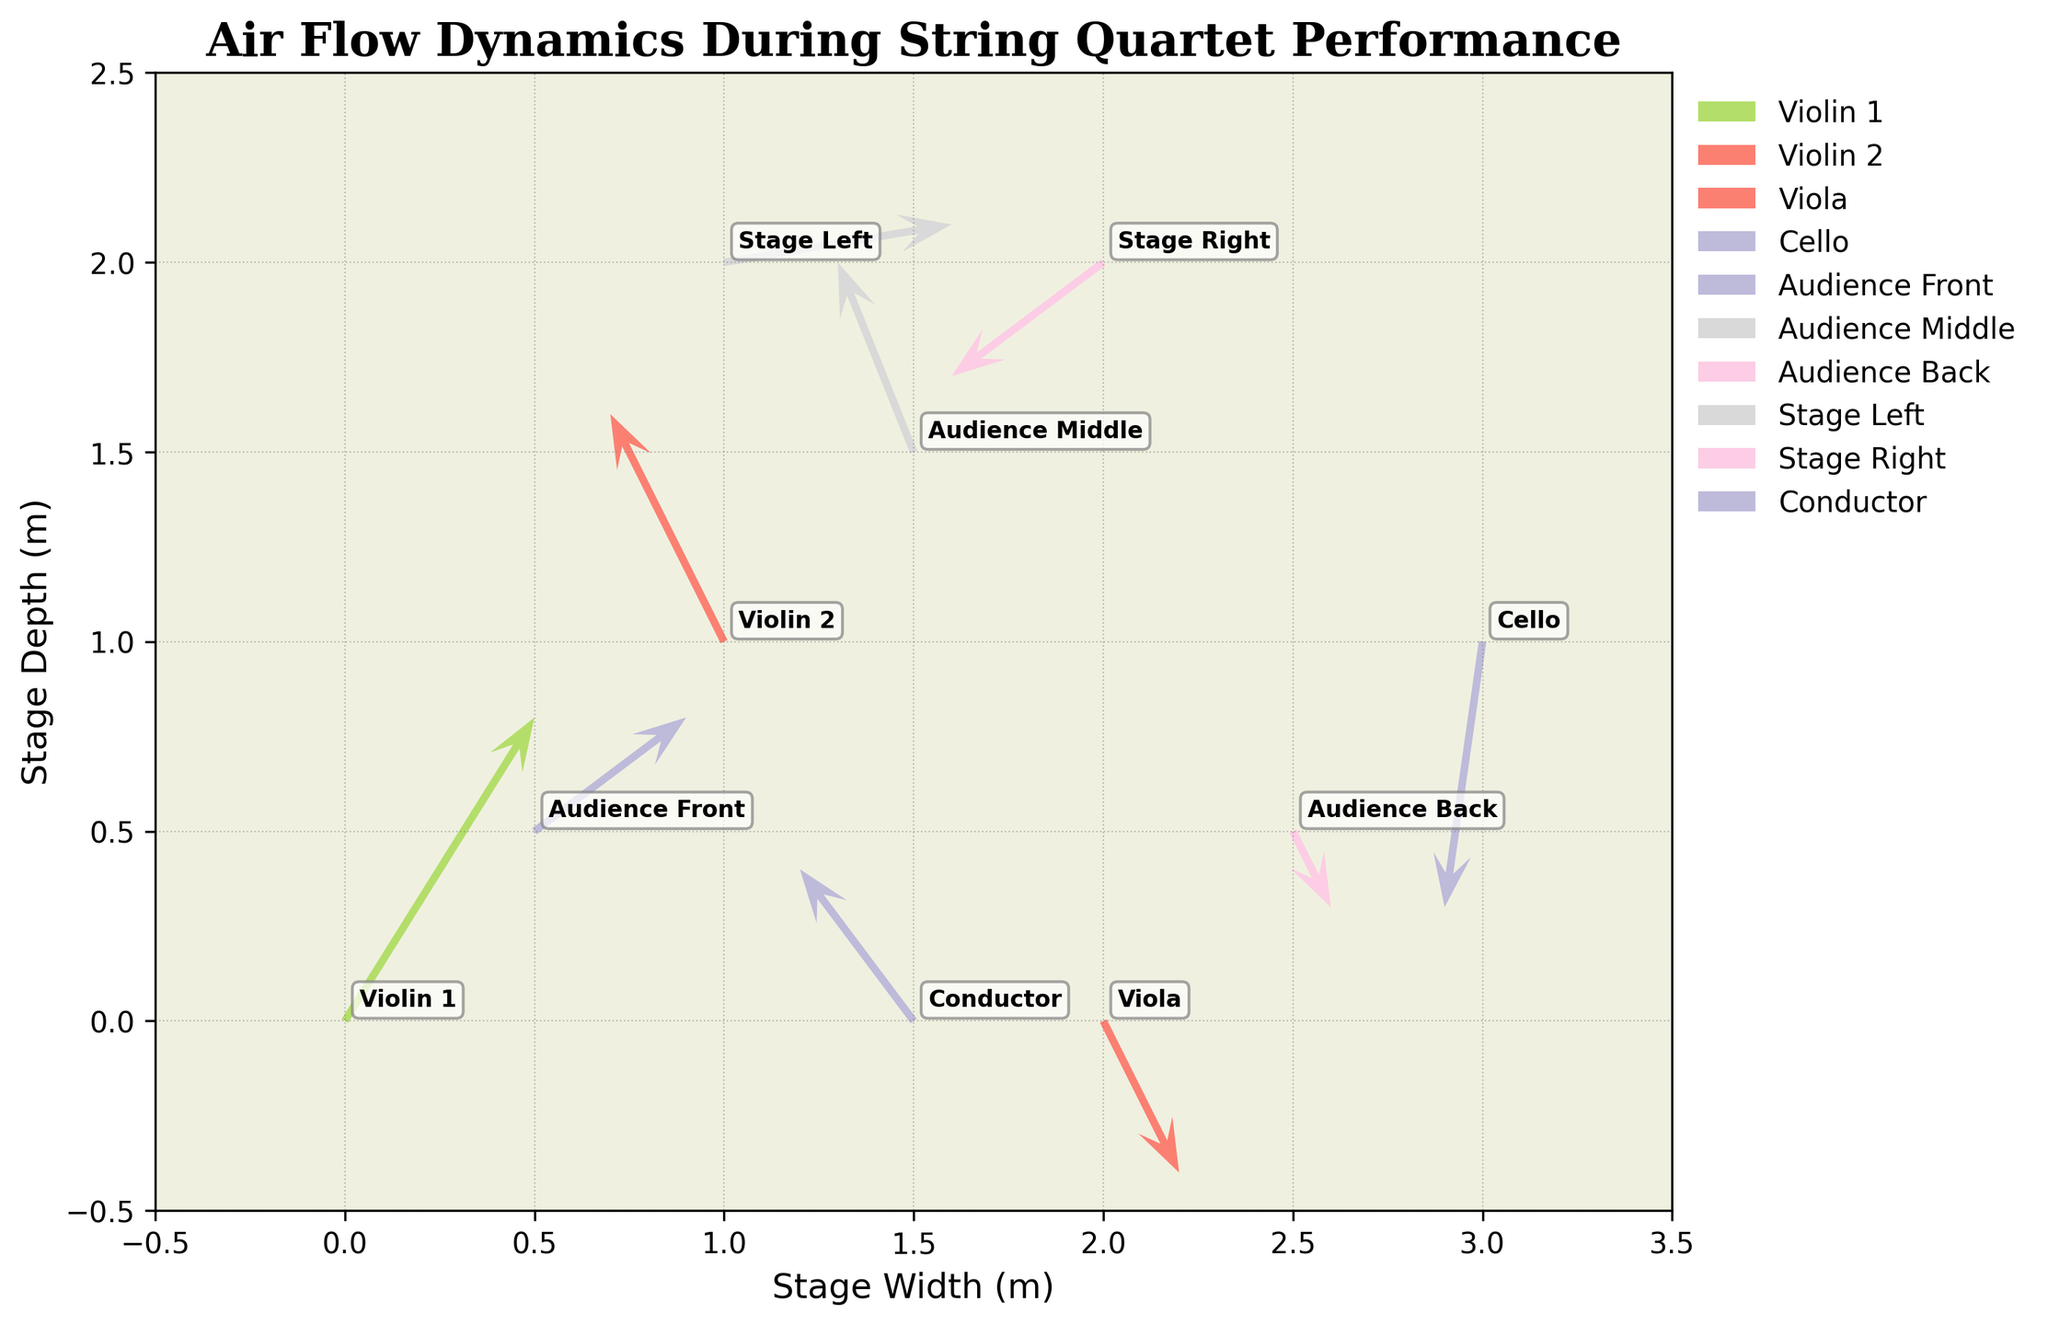What is the title of the figure? The title of the figure is typically located at the top center of the plot and provides a brief description of the visualization.
Answer: Air Flow Dynamics During String Quartet Performance How many different instruments and audience positions are represented in the plot? Different elements of the plot can usually be identified through the legend, which lists all unique labels present in the data.
Answer: 9 Which instrument has the airflow vector with the largest magnitude and what is its magnitude? To determine the instrument with the largest airflow vector magnitude, calculate the magnitude sqrt(u^2 + v^2) for each instrument and compare them.
Answer: Violin 1, magnitude = sqrt(0.5^2 + 0.8^2) ≈ 0.94 Compare the direction of airflow vectors for Violin 2 and Cello. Which one has a more downward direction (negative v component)? By comparing the v components of both vectors, you can see which one has a larger negative value. Violin 2 has v=0.6 while Cello has v=-0.7.
Answer: Cello What is the average x-coordinate position of all the audience members? To find this, sum the x-coordinates of all audience members (0.5, 1.5, 2.5) and divide by the number of audience members, which is 3. (0.5 + 1.5 + 2.5) / 3 = 1.5
Answer: 1.5 Which segment of the audience (Front, Middle, Back) has the smallest airflow vector magnitude and what is that magnitude? Calculate the magnitude of the airflow vectors for Audience Front, Middle, and Back, and then compare these magnitudes. For Audience Front sqrt(0.4^2 + 0.3^2) ≈ 0.5, Audience Middle sqrt((-0.2)^2 + 0.5^2) ≈ 0.54, Audience Back sqrt(0.1^2 + (-0.2)^2) ≈ 0.22.
Answer: Audience Back, magnitude = 0.22 Which has a stronger horizontal airflow component between the Conductor and Stage Left? Compare the absolute value of the u (horizontal) components of the vectors: Conductor has u=-0.3 and Stage Left has u=0.6, hence Stage Left's airflow component is stronger.
Answer: Stage Left Which quadrants (defined as positive/negative x and y regions) do the Violin 1 and Cello vectors lie in? Violin 1 has coordinates (0,0) and Cello has (3,1). Violin 1 lies at the origin (boundary of quadrants) while Cello lies in the first quadrant (positive x, positive y).
Answer: Violin 1: Origin, Cello: 1st Quadrant 